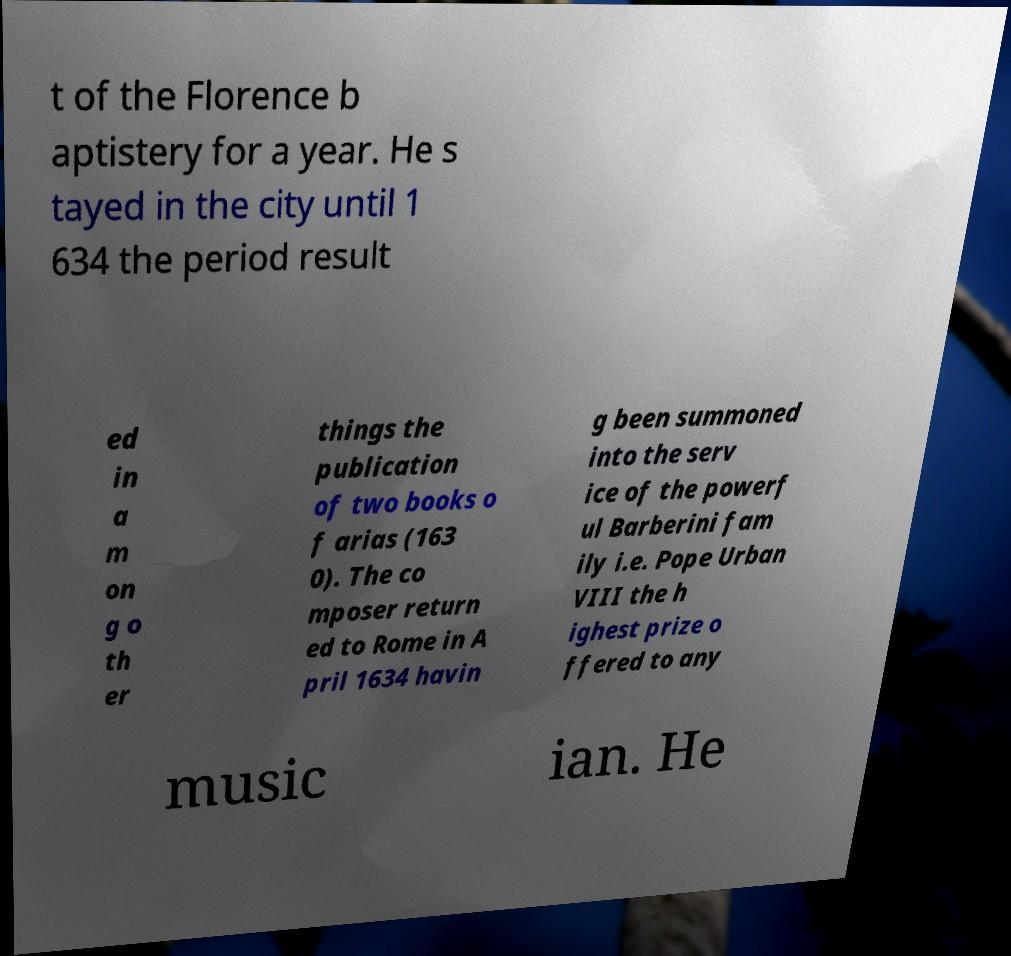Please read and relay the text visible in this image. What does it say? t of the Florence b aptistery for a year. He s tayed in the city until 1 634 the period result ed in a m on g o th er things the publication of two books o f arias (163 0). The co mposer return ed to Rome in A pril 1634 havin g been summoned into the serv ice of the powerf ul Barberini fam ily i.e. Pope Urban VIII the h ighest prize o ffered to any music ian. He 